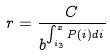Convert formula to latex. <formula><loc_0><loc_0><loc_500><loc_500>r = \frac { C } { b ^ { \int _ { i _ { 3 } } ^ { x } P ( i ) d i } }</formula> 